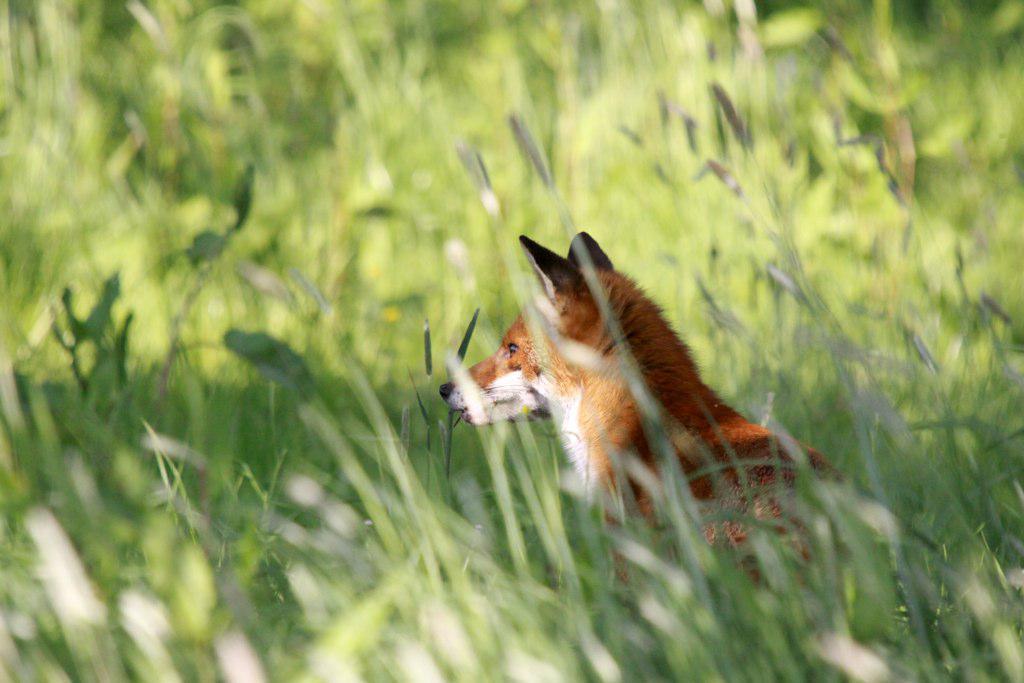How would you summarize this image in a sentence or two? In this picture I can see the fox in the farmland. In the background I can see many plants. 